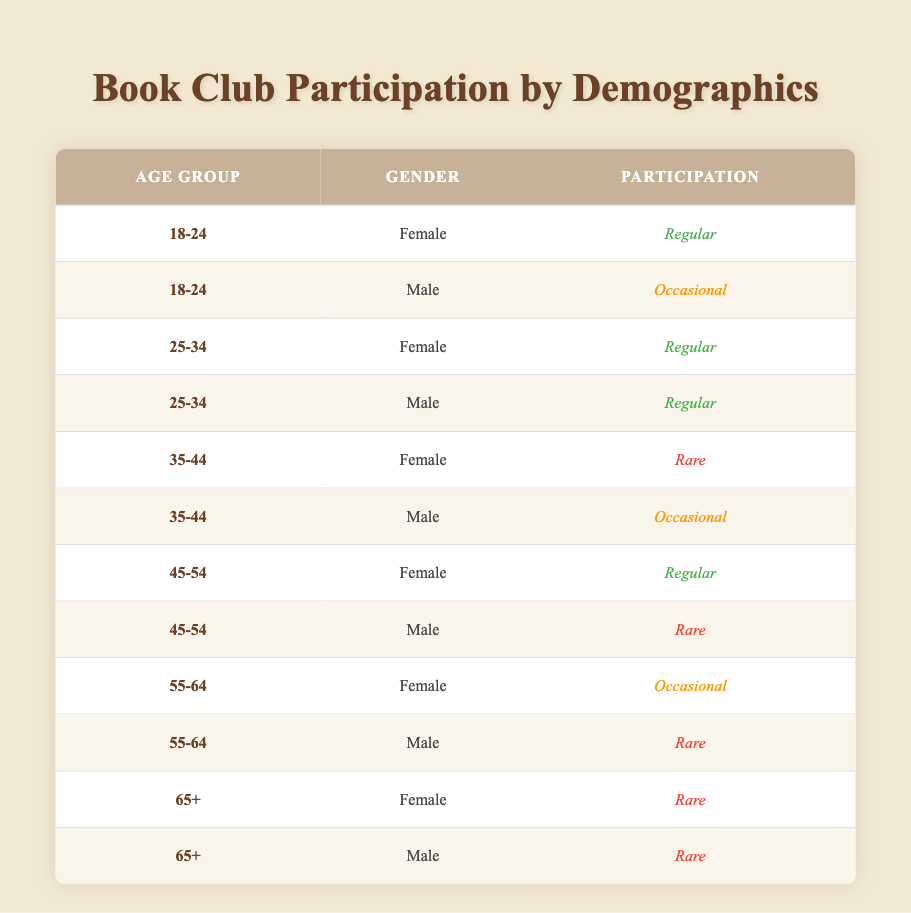What is the participation type for females in the age group 18-24? In the table, I can find the row corresponding to the age group 18-24 and gender Female. The participation type listed there is "Regular."
Answer: Regular What percentage of males in the age group 25-34 participate regularly? There are two males in the age group 25-34, and both of them have "Regular" participation. To find the percentage, I divide the number of regular participants (2) by the total number of males in this age group (2), then multiply by 100: (2/2) * 100 = 100%.
Answer: 100% Is there any female in the age group 55-64 who participates regularly? Looking at the 55-64 age group for females, the table shows that their participation type is "Occasional," which means there is no female who participates regularly in this group.
Answer: No How many females participate regularly across all age groups? I will go through each age group's female participants in the table. The age groups with "Regular" participation are 18-24, 25-34, and 45-54, contributing a total of 3 females.
Answer: 3 Are there more males who participate occasionally than females who participate regularly in the age group 35-44? In the 35-44 age group, one male has "Occasional" participation, while the female has "Rare" participation. Therefore, comparing this, males who participate occasionally (1) are more than females who participate regularly (0).
Answer: Yes What is the total number of participants in the age group 65+? For the age group 65+, I locate two entries (one for each gender). Since both entries indicate "Rare" participation, the total count of participants in the age group 65+ is 2.
Answer: 2 Which age group has the highest proportion of regular participants? By examining all age groups, I note that in the 25-34 age group, 100% of males and females participate regularly. So, the highest proportion belongs to the 25-34 age group.
Answer: 25-34 How many males in the age group 45-54 have rare participation? Reviewing the table, I find that in the 45-54 age group, there is only 1 male participant categorized as having "Rare" participation.
Answer: 1 